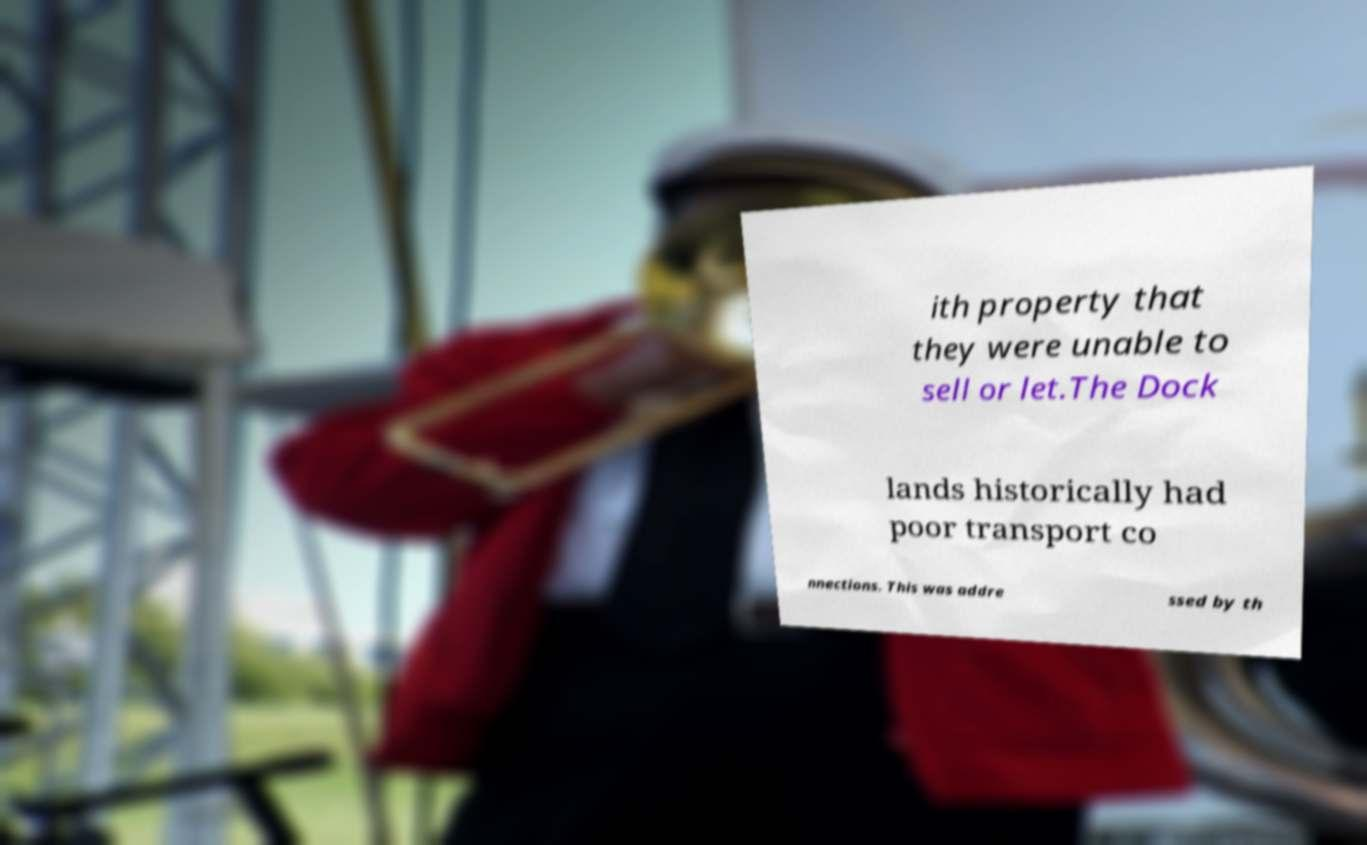There's text embedded in this image that I need extracted. Can you transcribe it verbatim? ith property that they were unable to sell or let.The Dock lands historically had poor transport co nnections. This was addre ssed by th 